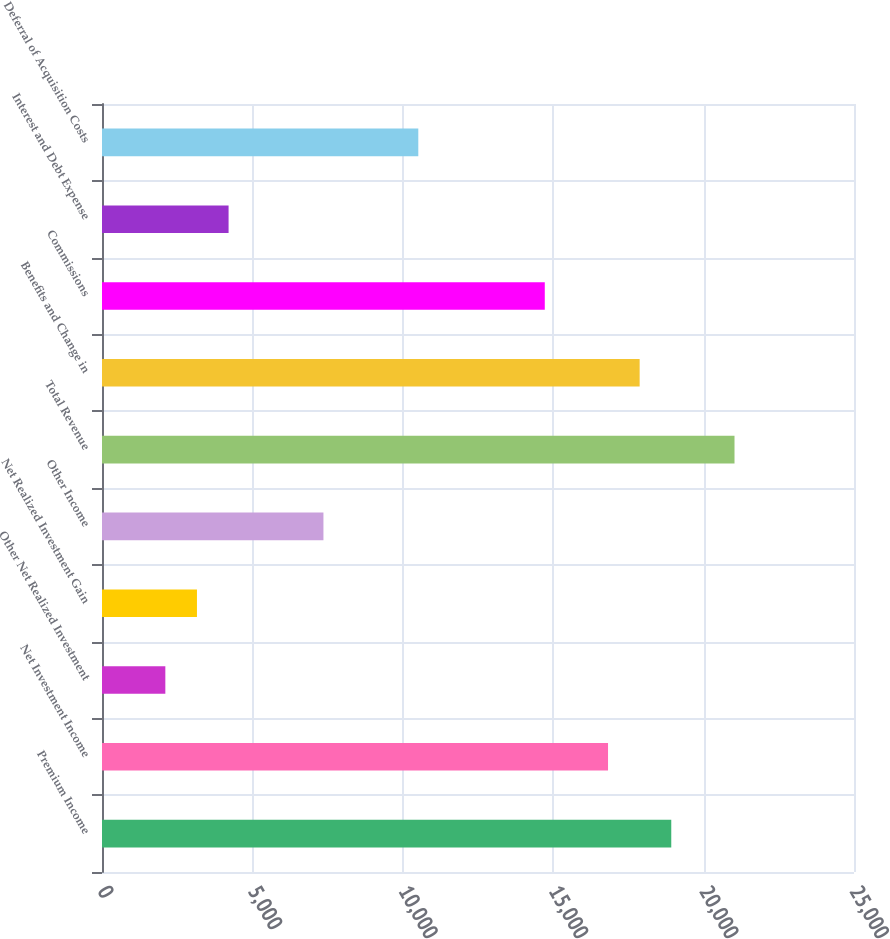Convert chart to OTSL. <chart><loc_0><loc_0><loc_500><loc_500><bar_chart><fcel>Premium Income<fcel>Net Investment Income<fcel>Other Net Realized Investment<fcel>Net Realized Investment Gain<fcel>Other Income<fcel>Total Revenue<fcel>Benefits and Change in<fcel>Commissions<fcel>Interest and Debt Expense<fcel>Deferral of Acquisition Costs<nl><fcel>18925.1<fcel>16822.7<fcel>2105.61<fcel>3156.83<fcel>7361.71<fcel>21027.6<fcel>17873.9<fcel>14720.2<fcel>4208.05<fcel>10515.4<nl></chart> 